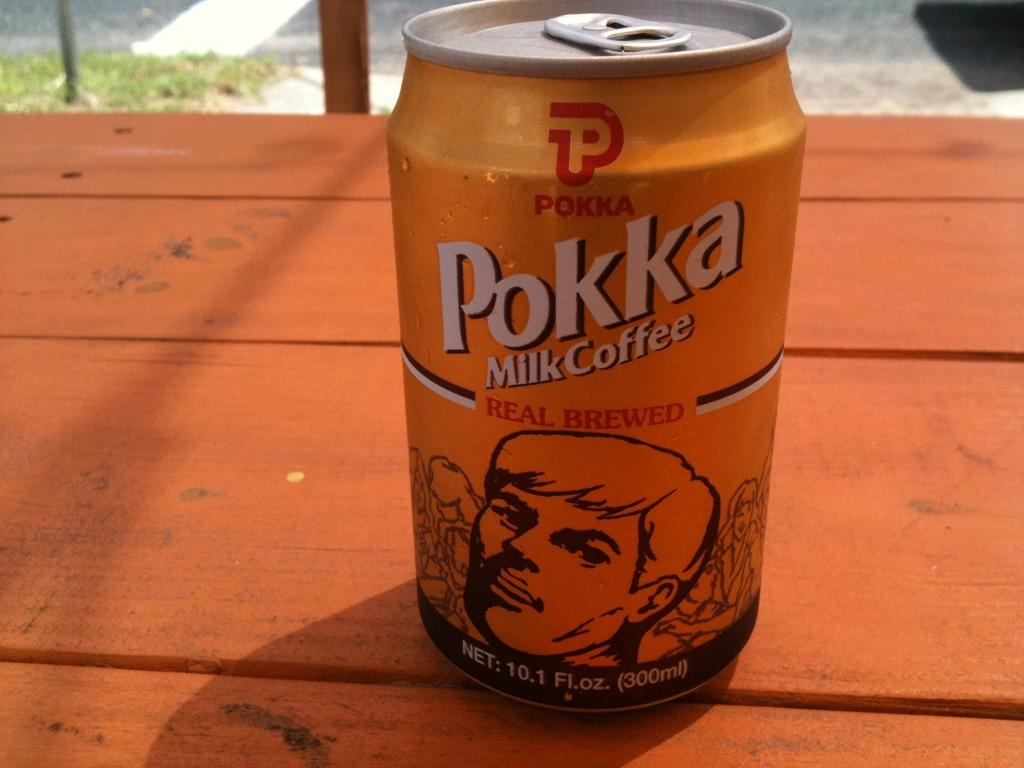<image>
Present a compact description of the photo's key features. The can on a wood table outside is Pokka Milk Coffee. 